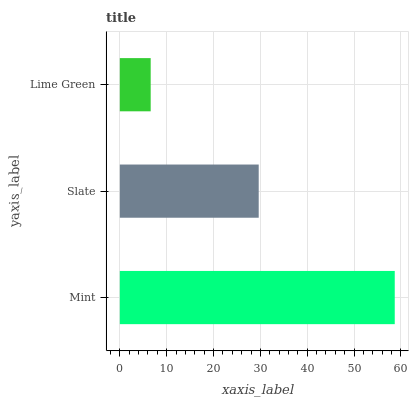Is Lime Green the minimum?
Answer yes or no. Yes. Is Mint the maximum?
Answer yes or no. Yes. Is Slate the minimum?
Answer yes or no. No. Is Slate the maximum?
Answer yes or no. No. Is Mint greater than Slate?
Answer yes or no. Yes. Is Slate less than Mint?
Answer yes or no. Yes. Is Slate greater than Mint?
Answer yes or no. No. Is Mint less than Slate?
Answer yes or no. No. Is Slate the high median?
Answer yes or no. Yes. Is Slate the low median?
Answer yes or no. Yes. Is Lime Green the high median?
Answer yes or no. No. Is Lime Green the low median?
Answer yes or no. No. 